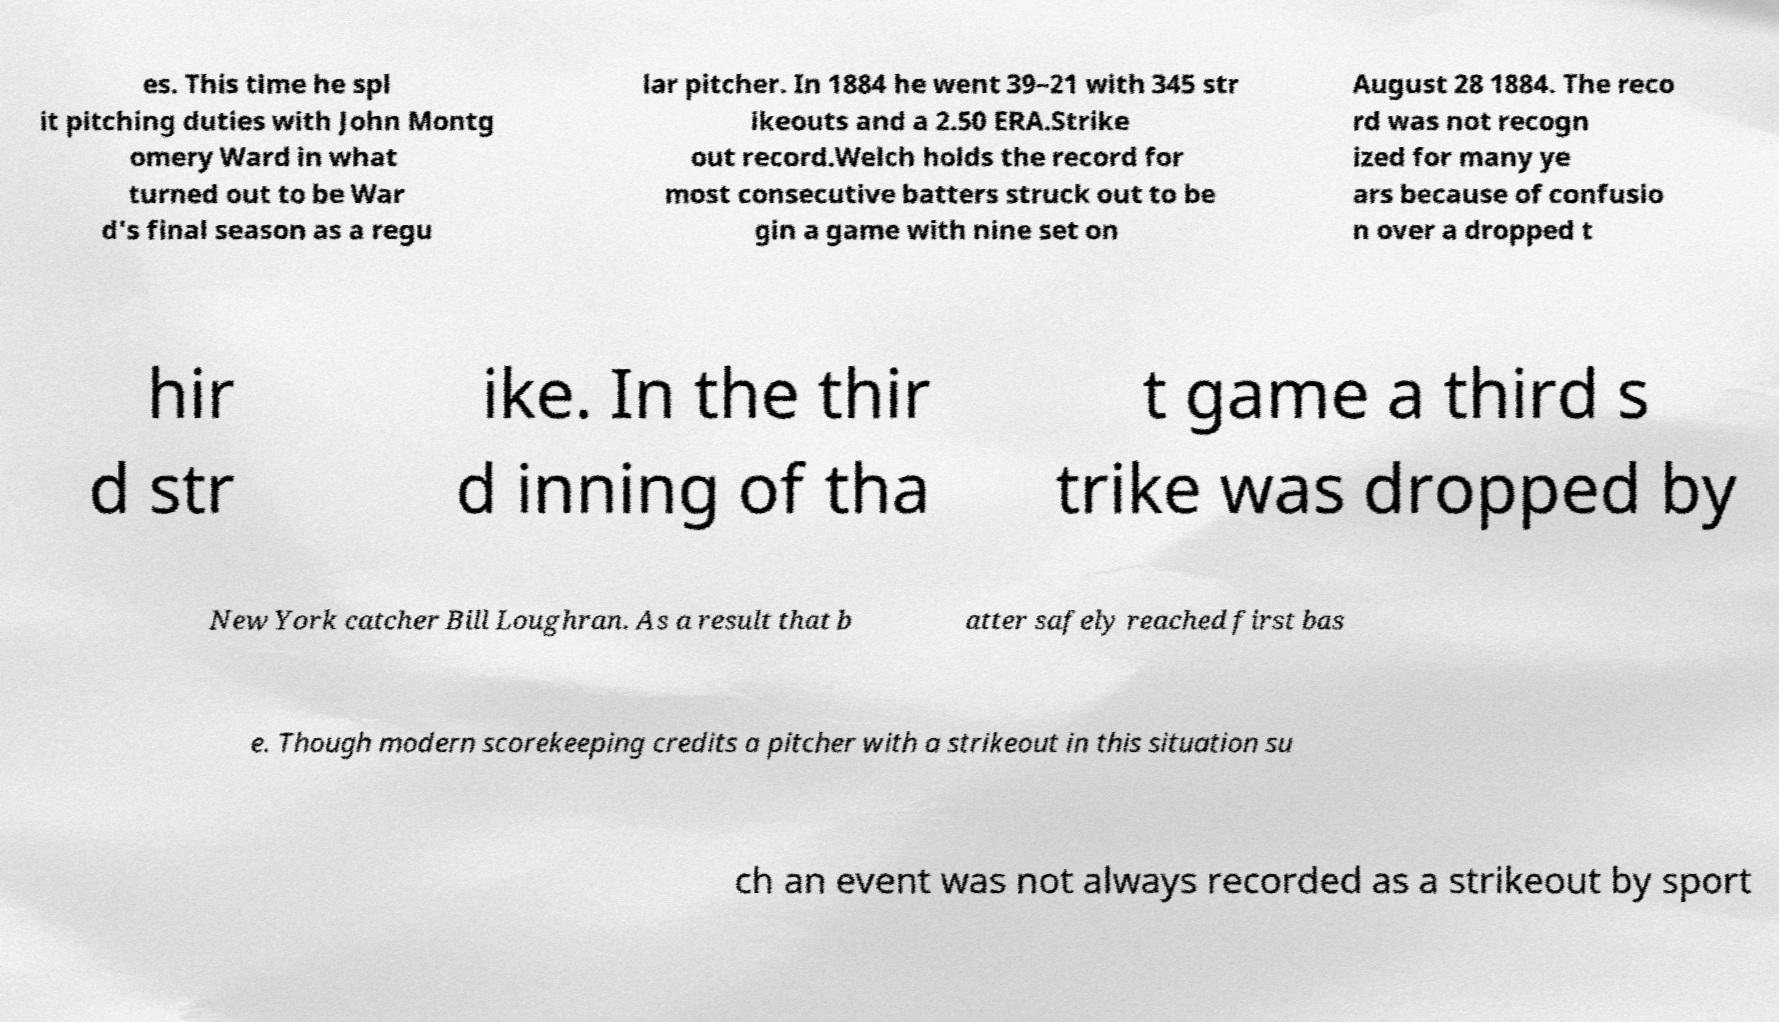Can you accurately transcribe the text from the provided image for me? es. This time he spl it pitching duties with John Montg omery Ward in what turned out to be War d's final season as a regu lar pitcher. In 1884 he went 39–21 with 345 str ikeouts and a 2.50 ERA.Strike out record.Welch holds the record for most consecutive batters struck out to be gin a game with nine set on August 28 1884. The reco rd was not recogn ized for many ye ars because of confusio n over a dropped t hir d str ike. In the thir d inning of tha t game a third s trike was dropped by New York catcher Bill Loughran. As a result that b atter safely reached first bas e. Though modern scorekeeping credits a pitcher with a strikeout in this situation su ch an event was not always recorded as a strikeout by sport 